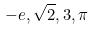<formula> <loc_0><loc_0><loc_500><loc_500>- e , \sqrt { 2 } , 3 , \pi</formula> 